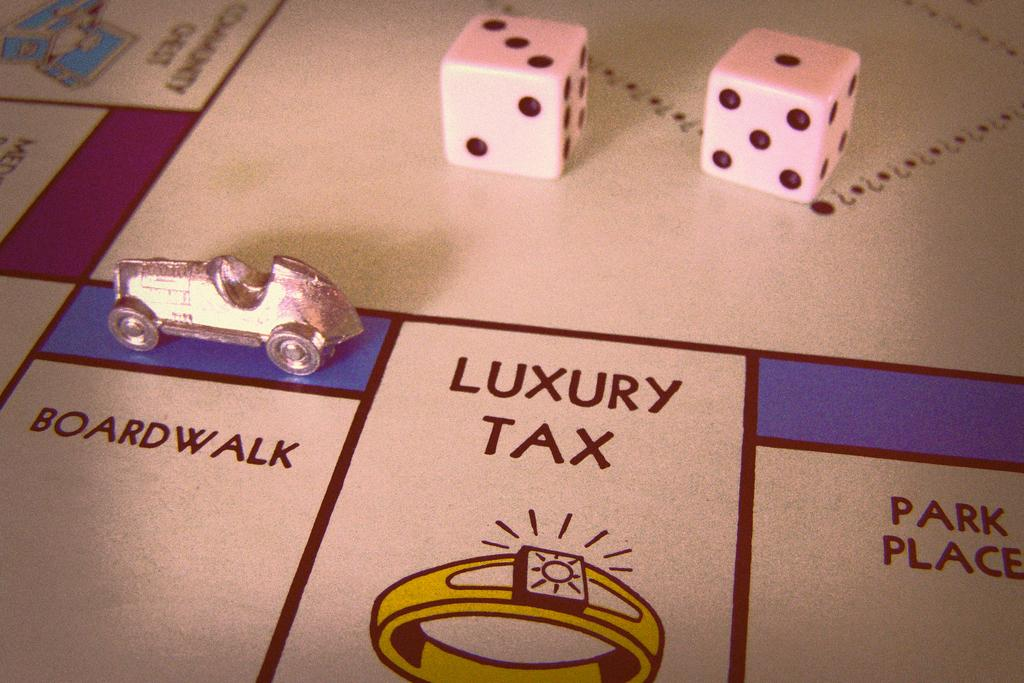What type of game pieces can be seen in the image? There are dice in the image. What other object is present in the image? There is a toy car in the image. Can you describe the board in the image? The board has text and design in the image. How many frogs are sitting on the vase in the image? There is no vase or frogs present in the image. 